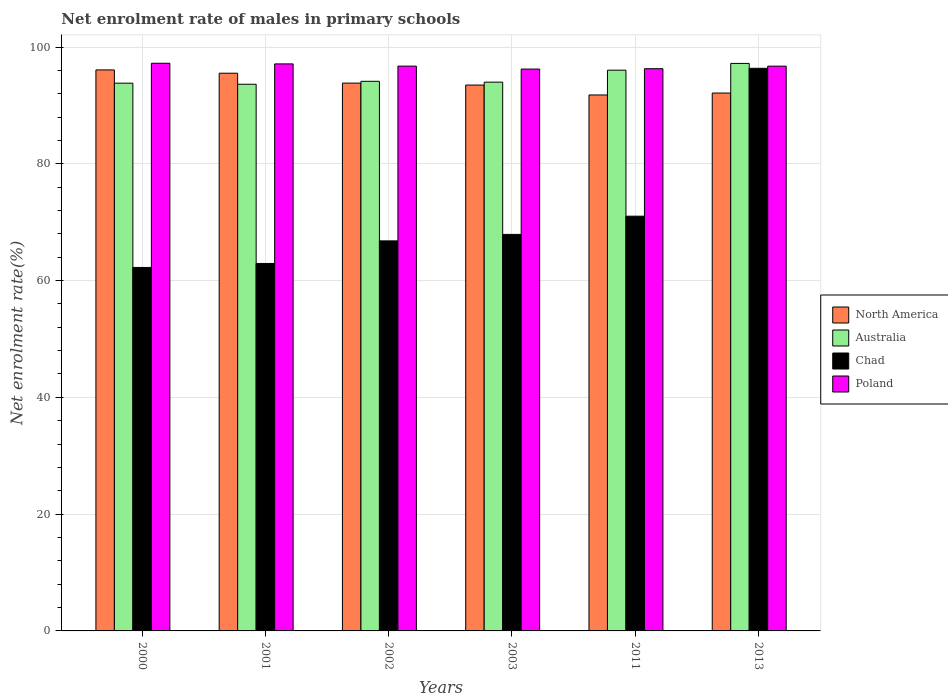How many groups of bars are there?
Offer a very short reply. 6. How many bars are there on the 6th tick from the right?
Ensure brevity in your answer.  4. In how many cases, is the number of bars for a given year not equal to the number of legend labels?
Your answer should be compact. 0. What is the net enrolment rate of males in primary schools in Australia in 2000?
Make the answer very short. 93.81. Across all years, what is the maximum net enrolment rate of males in primary schools in Poland?
Your answer should be very brief. 97.22. Across all years, what is the minimum net enrolment rate of males in primary schools in North America?
Offer a very short reply. 91.79. In which year was the net enrolment rate of males in primary schools in Chad minimum?
Provide a succinct answer. 2000. What is the total net enrolment rate of males in primary schools in North America in the graph?
Provide a short and direct response. 562.79. What is the difference between the net enrolment rate of males in primary schools in North America in 2003 and that in 2013?
Offer a terse response. 1.37. What is the difference between the net enrolment rate of males in primary schools in Poland in 2003 and the net enrolment rate of males in primary schools in North America in 2013?
Provide a succinct answer. 4.1. What is the average net enrolment rate of males in primary schools in Australia per year?
Offer a very short reply. 94.79. In the year 2013, what is the difference between the net enrolment rate of males in primary schools in North America and net enrolment rate of males in primary schools in Poland?
Your response must be concise. -4.61. In how many years, is the net enrolment rate of males in primary schools in Australia greater than 60 %?
Offer a very short reply. 6. What is the ratio of the net enrolment rate of males in primary schools in Australia in 2011 to that in 2013?
Your response must be concise. 0.99. What is the difference between the highest and the second highest net enrolment rate of males in primary schools in Chad?
Ensure brevity in your answer.  25.33. What is the difference between the highest and the lowest net enrolment rate of males in primary schools in Poland?
Your answer should be compact. 1. What does the 2nd bar from the right in 2013 represents?
Provide a succinct answer. Chad. Is it the case that in every year, the sum of the net enrolment rate of males in primary schools in Australia and net enrolment rate of males in primary schools in Chad is greater than the net enrolment rate of males in primary schools in Poland?
Give a very brief answer. Yes. How many bars are there?
Provide a succinct answer. 24. How many years are there in the graph?
Your response must be concise. 6. Are the values on the major ticks of Y-axis written in scientific E-notation?
Make the answer very short. No. Does the graph contain any zero values?
Offer a very short reply. No. Does the graph contain grids?
Provide a succinct answer. Yes. Where does the legend appear in the graph?
Offer a terse response. Center right. What is the title of the graph?
Give a very brief answer. Net enrolment rate of males in primary schools. Does "Lithuania" appear as one of the legend labels in the graph?
Provide a short and direct response. No. What is the label or title of the X-axis?
Your answer should be very brief. Years. What is the label or title of the Y-axis?
Make the answer very short. Net enrolment rate(%). What is the Net enrolment rate(%) of North America in 2000?
Ensure brevity in your answer.  96.08. What is the Net enrolment rate(%) in Australia in 2000?
Keep it short and to the point. 93.81. What is the Net enrolment rate(%) of Chad in 2000?
Keep it short and to the point. 62.25. What is the Net enrolment rate(%) in Poland in 2000?
Your answer should be very brief. 97.22. What is the Net enrolment rate(%) in North America in 2001?
Offer a terse response. 95.51. What is the Net enrolment rate(%) in Australia in 2001?
Give a very brief answer. 93.62. What is the Net enrolment rate(%) in Chad in 2001?
Provide a succinct answer. 62.93. What is the Net enrolment rate(%) in Poland in 2001?
Keep it short and to the point. 97.11. What is the Net enrolment rate(%) of North America in 2002?
Offer a very short reply. 93.82. What is the Net enrolment rate(%) in Australia in 2002?
Keep it short and to the point. 94.13. What is the Net enrolment rate(%) in Chad in 2002?
Give a very brief answer. 66.8. What is the Net enrolment rate(%) of Poland in 2002?
Keep it short and to the point. 96.73. What is the Net enrolment rate(%) in North America in 2003?
Give a very brief answer. 93.48. What is the Net enrolment rate(%) of Australia in 2003?
Ensure brevity in your answer.  93.98. What is the Net enrolment rate(%) in Chad in 2003?
Provide a short and direct response. 67.91. What is the Net enrolment rate(%) of Poland in 2003?
Your answer should be very brief. 96.22. What is the Net enrolment rate(%) of North America in 2011?
Your answer should be compact. 91.79. What is the Net enrolment rate(%) of Australia in 2011?
Offer a terse response. 96.03. What is the Net enrolment rate(%) in Chad in 2011?
Give a very brief answer. 71.03. What is the Net enrolment rate(%) of Poland in 2011?
Provide a short and direct response. 96.28. What is the Net enrolment rate(%) of North America in 2013?
Keep it short and to the point. 92.12. What is the Net enrolment rate(%) in Australia in 2013?
Offer a terse response. 97.19. What is the Net enrolment rate(%) in Chad in 2013?
Make the answer very short. 96.35. What is the Net enrolment rate(%) of Poland in 2013?
Offer a very short reply. 96.72. Across all years, what is the maximum Net enrolment rate(%) in North America?
Offer a terse response. 96.08. Across all years, what is the maximum Net enrolment rate(%) in Australia?
Offer a terse response. 97.19. Across all years, what is the maximum Net enrolment rate(%) of Chad?
Your answer should be very brief. 96.35. Across all years, what is the maximum Net enrolment rate(%) in Poland?
Provide a short and direct response. 97.22. Across all years, what is the minimum Net enrolment rate(%) in North America?
Offer a terse response. 91.79. Across all years, what is the minimum Net enrolment rate(%) of Australia?
Make the answer very short. 93.62. Across all years, what is the minimum Net enrolment rate(%) in Chad?
Your response must be concise. 62.25. Across all years, what is the minimum Net enrolment rate(%) of Poland?
Give a very brief answer. 96.22. What is the total Net enrolment rate(%) of North America in the graph?
Provide a short and direct response. 562.79. What is the total Net enrolment rate(%) of Australia in the graph?
Make the answer very short. 568.76. What is the total Net enrolment rate(%) in Chad in the graph?
Keep it short and to the point. 427.26. What is the total Net enrolment rate(%) of Poland in the graph?
Offer a terse response. 580.27. What is the difference between the Net enrolment rate(%) in North America in 2000 and that in 2001?
Your answer should be compact. 0.56. What is the difference between the Net enrolment rate(%) in Australia in 2000 and that in 2001?
Offer a very short reply. 0.18. What is the difference between the Net enrolment rate(%) in Chad in 2000 and that in 2001?
Make the answer very short. -0.68. What is the difference between the Net enrolment rate(%) of Poland in 2000 and that in 2001?
Provide a short and direct response. 0.11. What is the difference between the Net enrolment rate(%) of North America in 2000 and that in 2002?
Provide a short and direct response. 2.26. What is the difference between the Net enrolment rate(%) in Australia in 2000 and that in 2002?
Provide a short and direct response. -0.32. What is the difference between the Net enrolment rate(%) in Chad in 2000 and that in 2002?
Offer a terse response. -4.55. What is the difference between the Net enrolment rate(%) of Poland in 2000 and that in 2002?
Offer a very short reply. 0.49. What is the difference between the Net enrolment rate(%) in North America in 2000 and that in 2003?
Offer a terse response. 2.59. What is the difference between the Net enrolment rate(%) in Australia in 2000 and that in 2003?
Keep it short and to the point. -0.17. What is the difference between the Net enrolment rate(%) in Chad in 2000 and that in 2003?
Provide a succinct answer. -5.66. What is the difference between the Net enrolment rate(%) of North America in 2000 and that in 2011?
Keep it short and to the point. 4.29. What is the difference between the Net enrolment rate(%) of Australia in 2000 and that in 2011?
Provide a succinct answer. -2.23. What is the difference between the Net enrolment rate(%) in Chad in 2000 and that in 2011?
Your answer should be compact. -8.78. What is the difference between the Net enrolment rate(%) of Poland in 2000 and that in 2011?
Make the answer very short. 0.93. What is the difference between the Net enrolment rate(%) of North America in 2000 and that in 2013?
Your answer should be very brief. 3.96. What is the difference between the Net enrolment rate(%) in Australia in 2000 and that in 2013?
Provide a short and direct response. -3.38. What is the difference between the Net enrolment rate(%) in Chad in 2000 and that in 2013?
Offer a very short reply. -34.11. What is the difference between the Net enrolment rate(%) of Poland in 2000 and that in 2013?
Keep it short and to the point. 0.49. What is the difference between the Net enrolment rate(%) in North America in 2001 and that in 2002?
Your answer should be very brief. 1.69. What is the difference between the Net enrolment rate(%) in Australia in 2001 and that in 2002?
Your response must be concise. -0.5. What is the difference between the Net enrolment rate(%) of Chad in 2001 and that in 2002?
Make the answer very short. -3.87. What is the difference between the Net enrolment rate(%) of Poland in 2001 and that in 2002?
Provide a short and direct response. 0.38. What is the difference between the Net enrolment rate(%) in North America in 2001 and that in 2003?
Provide a short and direct response. 2.03. What is the difference between the Net enrolment rate(%) in Australia in 2001 and that in 2003?
Your answer should be compact. -0.36. What is the difference between the Net enrolment rate(%) of Chad in 2001 and that in 2003?
Provide a short and direct response. -4.98. What is the difference between the Net enrolment rate(%) of Poland in 2001 and that in 2003?
Give a very brief answer. 0.89. What is the difference between the Net enrolment rate(%) in North America in 2001 and that in 2011?
Offer a very short reply. 3.73. What is the difference between the Net enrolment rate(%) in Australia in 2001 and that in 2011?
Ensure brevity in your answer.  -2.41. What is the difference between the Net enrolment rate(%) in Chad in 2001 and that in 2011?
Provide a short and direct response. -8.1. What is the difference between the Net enrolment rate(%) in Poland in 2001 and that in 2011?
Give a very brief answer. 0.82. What is the difference between the Net enrolment rate(%) in North America in 2001 and that in 2013?
Offer a very short reply. 3.4. What is the difference between the Net enrolment rate(%) of Australia in 2001 and that in 2013?
Your response must be concise. -3.56. What is the difference between the Net enrolment rate(%) of Chad in 2001 and that in 2013?
Provide a succinct answer. -33.42. What is the difference between the Net enrolment rate(%) in Poland in 2001 and that in 2013?
Your answer should be compact. 0.38. What is the difference between the Net enrolment rate(%) in North America in 2002 and that in 2003?
Provide a succinct answer. 0.33. What is the difference between the Net enrolment rate(%) of Australia in 2002 and that in 2003?
Your answer should be compact. 0.15. What is the difference between the Net enrolment rate(%) of Chad in 2002 and that in 2003?
Offer a very short reply. -1.11. What is the difference between the Net enrolment rate(%) of Poland in 2002 and that in 2003?
Offer a terse response. 0.51. What is the difference between the Net enrolment rate(%) of North America in 2002 and that in 2011?
Give a very brief answer. 2.03. What is the difference between the Net enrolment rate(%) in Australia in 2002 and that in 2011?
Your answer should be very brief. -1.91. What is the difference between the Net enrolment rate(%) in Chad in 2002 and that in 2011?
Your answer should be compact. -4.23. What is the difference between the Net enrolment rate(%) of Poland in 2002 and that in 2011?
Keep it short and to the point. 0.44. What is the difference between the Net enrolment rate(%) of North America in 2002 and that in 2013?
Provide a short and direct response. 1.7. What is the difference between the Net enrolment rate(%) of Australia in 2002 and that in 2013?
Provide a succinct answer. -3.06. What is the difference between the Net enrolment rate(%) of Chad in 2002 and that in 2013?
Offer a terse response. -29.55. What is the difference between the Net enrolment rate(%) in Poland in 2002 and that in 2013?
Make the answer very short. 0. What is the difference between the Net enrolment rate(%) of North America in 2003 and that in 2011?
Provide a short and direct response. 1.7. What is the difference between the Net enrolment rate(%) in Australia in 2003 and that in 2011?
Provide a short and direct response. -2.05. What is the difference between the Net enrolment rate(%) in Chad in 2003 and that in 2011?
Provide a short and direct response. -3.12. What is the difference between the Net enrolment rate(%) in Poland in 2003 and that in 2011?
Your response must be concise. -0.06. What is the difference between the Net enrolment rate(%) in North America in 2003 and that in 2013?
Provide a short and direct response. 1.37. What is the difference between the Net enrolment rate(%) in Australia in 2003 and that in 2013?
Ensure brevity in your answer.  -3.21. What is the difference between the Net enrolment rate(%) of Chad in 2003 and that in 2013?
Your answer should be compact. -28.45. What is the difference between the Net enrolment rate(%) in Poland in 2003 and that in 2013?
Make the answer very short. -0.5. What is the difference between the Net enrolment rate(%) in North America in 2011 and that in 2013?
Give a very brief answer. -0.33. What is the difference between the Net enrolment rate(%) in Australia in 2011 and that in 2013?
Make the answer very short. -1.15. What is the difference between the Net enrolment rate(%) in Chad in 2011 and that in 2013?
Provide a short and direct response. -25.33. What is the difference between the Net enrolment rate(%) of Poland in 2011 and that in 2013?
Give a very brief answer. -0.44. What is the difference between the Net enrolment rate(%) of North America in 2000 and the Net enrolment rate(%) of Australia in 2001?
Provide a short and direct response. 2.45. What is the difference between the Net enrolment rate(%) in North America in 2000 and the Net enrolment rate(%) in Chad in 2001?
Offer a very short reply. 33.15. What is the difference between the Net enrolment rate(%) of North America in 2000 and the Net enrolment rate(%) of Poland in 2001?
Provide a succinct answer. -1.03. What is the difference between the Net enrolment rate(%) of Australia in 2000 and the Net enrolment rate(%) of Chad in 2001?
Your answer should be very brief. 30.88. What is the difference between the Net enrolment rate(%) in Australia in 2000 and the Net enrolment rate(%) in Poland in 2001?
Provide a succinct answer. -3.3. What is the difference between the Net enrolment rate(%) of Chad in 2000 and the Net enrolment rate(%) of Poland in 2001?
Offer a terse response. -34.86. What is the difference between the Net enrolment rate(%) of North America in 2000 and the Net enrolment rate(%) of Australia in 2002?
Keep it short and to the point. 1.95. What is the difference between the Net enrolment rate(%) of North America in 2000 and the Net enrolment rate(%) of Chad in 2002?
Offer a very short reply. 29.28. What is the difference between the Net enrolment rate(%) in North America in 2000 and the Net enrolment rate(%) in Poland in 2002?
Offer a very short reply. -0.65. What is the difference between the Net enrolment rate(%) in Australia in 2000 and the Net enrolment rate(%) in Chad in 2002?
Your response must be concise. 27.01. What is the difference between the Net enrolment rate(%) of Australia in 2000 and the Net enrolment rate(%) of Poland in 2002?
Your answer should be very brief. -2.92. What is the difference between the Net enrolment rate(%) in Chad in 2000 and the Net enrolment rate(%) in Poland in 2002?
Provide a succinct answer. -34.48. What is the difference between the Net enrolment rate(%) in North America in 2000 and the Net enrolment rate(%) in Australia in 2003?
Ensure brevity in your answer.  2.09. What is the difference between the Net enrolment rate(%) in North America in 2000 and the Net enrolment rate(%) in Chad in 2003?
Ensure brevity in your answer.  28.17. What is the difference between the Net enrolment rate(%) of North America in 2000 and the Net enrolment rate(%) of Poland in 2003?
Ensure brevity in your answer.  -0.15. What is the difference between the Net enrolment rate(%) in Australia in 2000 and the Net enrolment rate(%) in Chad in 2003?
Your response must be concise. 25.9. What is the difference between the Net enrolment rate(%) of Australia in 2000 and the Net enrolment rate(%) of Poland in 2003?
Provide a short and direct response. -2.41. What is the difference between the Net enrolment rate(%) in Chad in 2000 and the Net enrolment rate(%) in Poland in 2003?
Provide a short and direct response. -33.97. What is the difference between the Net enrolment rate(%) of North America in 2000 and the Net enrolment rate(%) of Australia in 2011?
Ensure brevity in your answer.  0.04. What is the difference between the Net enrolment rate(%) of North America in 2000 and the Net enrolment rate(%) of Chad in 2011?
Keep it short and to the point. 25.05. What is the difference between the Net enrolment rate(%) in North America in 2000 and the Net enrolment rate(%) in Poland in 2011?
Keep it short and to the point. -0.21. What is the difference between the Net enrolment rate(%) of Australia in 2000 and the Net enrolment rate(%) of Chad in 2011?
Provide a short and direct response. 22.78. What is the difference between the Net enrolment rate(%) of Australia in 2000 and the Net enrolment rate(%) of Poland in 2011?
Offer a terse response. -2.47. What is the difference between the Net enrolment rate(%) of Chad in 2000 and the Net enrolment rate(%) of Poland in 2011?
Keep it short and to the point. -34.03. What is the difference between the Net enrolment rate(%) of North America in 2000 and the Net enrolment rate(%) of Australia in 2013?
Your answer should be compact. -1.11. What is the difference between the Net enrolment rate(%) in North America in 2000 and the Net enrolment rate(%) in Chad in 2013?
Ensure brevity in your answer.  -0.28. What is the difference between the Net enrolment rate(%) in North America in 2000 and the Net enrolment rate(%) in Poland in 2013?
Provide a succinct answer. -0.65. What is the difference between the Net enrolment rate(%) of Australia in 2000 and the Net enrolment rate(%) of Chad in 2013?
Make the answer very short. -2.55. What is the difference between the Net enrolment rate(%) in Australia in 2000 and the Net enrolment rate(%) in Poland in 2013?
Make the answer very short. -2.92. What is the difference between the Net enrolment rate(%) of Chad in 2000 and the Net enrolment rate(%) of Poland in 2013?
Keep it short and to the point. -34.48. What is the difference between the Net enrolment rate(%) in North America in 2001 and the Net enrolment rate(%) in Australia in 2002?
Your answer should be very brief. 1.39. What is the difference between the Net enrolment rate(%) in North America in 2001 and the Net enrolment rate(%) in Chad in 2002?
Your answer should be very brief. 28.71. What is the difference between the Net enrolment rate(%) of North America in 2001 and the Net enrolment rate(%) of Poland in 2002?
Provide a short and direct response. -1.21. What is the difference between the Net enrolment rate(%) of Australia in 2001 and the Net enrolment rate(%) of Chad in 2002?
Your answer should be very brief. 26.83. What is the difference between the Net enrolment rate(%) in Australia in 2001 and the Net enrolment rate(%) in Poland in 2002?
Your answer should be very brief. -3.1. What is the difference between the Net enrolment rate(%) in Chad in 2001 and the Net enrolment rate(%) in Poland in 2002?
Your answer should be compact. -33.8. What is the difference between the Net enrolment rate(%) in North America in 2001 and the Net enrolment rate(%) in Australia in 2003?
Provide a succinct answer. 1.53. What is the difference between the Net enrolment rate(%) in North America in 2001 and the Net enrolment rate(%) in Chad in 2003?
Offer a terse response. 27.61. What is the difference between the Net enrolment rate(%) in North America in 2001 and the Net enrolment rate(%) in Poland in 2003?
Keep it short and to the point. -0.71. What is the difference between the Net enrolment rate(%) of Australia in 2001 and the Net enrolment rate(%) of Chad in 2003?
Offer a terse response. 25.72. What is the difference between the Net enrolment rate(%) of Australia in 2001 and the Net enrolment rate(%) of Poland in 2003?
Your answer should be very brief. -2.6. What is the difference between the Net enrolment rate(%) in Chad in 2001 and the Net enrolment rate(%) in Poland in 2003?
Provide a succinct answer. -33.29. What is the difference between the Net enrolment rate(%) of North America in 2001 and the Net enrolment rate(%) of Australia in 2011?
Give a very brief answer. -0.52. What is the difference between the Net enrolment rate(%) in North America in 2001 and the Net enrolment rate(%) in Chad in 2011?
Your answer should be very brief. 24.49. What is the difference between the Net enrolment rate(%) of North America in 2001 and the Net enrolment rate(%) of Poland in 2011?
Keep it short and to the point. -0.77. What is the difference between the Net enrolment rate(%) in Australia in 2001 and the Net enrolment rate(%) in Chad in 2011?
Your answer should be very brief. 22.6. What is the difference between the Net enrolment rate(%) in Australia in 2001 and the Net enrolment rate(%) in Poland in 2011?
Offer a very short reply. -2.66. What is the difference between the Net enrolment rate(%) in Chad in 2001 and the Net enrolment rate(%) in Poland in 2011?
Make the answer very short. -33.35. What is the difference between the Net enrolment rate(%) in North America in 2001 and the Net enrolment rate(%) in Australia in 2013?
Ensure brevity in your answer.  -1.68. What is the difference between the Net enrolment rate(%) in North America in 2001 and the Net enrolment rate(%) in Chad in 2013?
Your response must be concise. -0.84. What is the difference between the Net enrolment rate(%) in North America in 2001 and the Net enrolment rate(%) in Poland in 2013?
Make the answer very short. -1.21. What is the difference between the Net enrolment rate(%) of Australia in 2001 and the Net enrolment rate(%) of Chad in 2013?
Your answer should be very brief. -2.73. What is the difference between the Net enrolment rate(%) of Australia in 2001 and the Net enrolment rate(%) of Poland in 2013?
Make the answer very short. -3.1. What is the difference between the Net enrolment rate(%) of Chad in 2001 and the Net enrolment rate(%) of Poland in 2013?
Keep it short and to the point. -33.79. What is the difference between the Net enrolment rate(%) of North America in 2002 and the Net enrolment rate(%) of Australia in 2003?
Give a very brief answer. -0.16. What is the difference between the Net enrolment rate(%) of North America in 2002 and the Net enrolment rate(%) of Chad in 2003?
Your response must be concise. 25.91. What is the difference between the Net enrolment rate(%) in North America in 2002 and the Net enrolment rate(%) in Poland in 2003?
Give a very brief answer. -2.4. What is the difference between the Net enrolment rate(%) in Australia in 2002 and the Net enrolment rate(%) in Chad in 2003?
Your response must be concise. 26.22. What is the difference between the Net enrolment rate(%) of Australia in 2002 and the Net enrolment rate(%) of Poland in 2003?
Give a very brief answer. -2.09. What is the difference between the Net enrolment rate(%) in Chad in 2002 and the Net enrolment rate(%) in Poland in 2003?
Your answer should be very brief. -29.42. What is the difference between the Net enrolment rate(%) of North America in 2002 and the Net enrolment rate(%) of Australia in 2011?
Provide a short and direct response. -2.22. What is the difference between the Net enrolment rate(%) in North America in 2002 and the Net enrolment rate(%) in Chad in 2011?
Keep it short and to the point. 22.79. What is the difference between the Net enrolment rate(%) in North America in 2002 and the Net enrolment rate(%) in Poland in 2011?
Provide a short and direct response. -2.46. What is the difference between the Net enrolment rate(%) of Australia in 2002 and the Net enrolment rate(%) of Chad in 2011?
Your answer should be very brief. 23.1. What is the difference between the Net enrolment rate(%) of Australia in 2002 and the Net enrolment rate(%) of Poland in 2011?
Your answer should be very brief. -2.15. What is the difference between the Net enrolment rate(%) in Chad in 2002 and the Net enrolment rate(%) in Poland in 2011?
Provide a succinct answer. -29.48. What is the difference between the Net enrolment rate(%) of North America in 2002 and the Net enrolment rate(%) of Australia in 2013?
Your answer should be compact. -3.37. What is the difference between the Net enrolment rate(%) in North America in 2002 and the Net enrolment rate(%) in Chad in 2013?
Your answer should be very brief. -2.53. What is the difference between the Net enrolment rate(%) in North America in 2002 and the Net enrolment rate(%) in Poland in 2013?
Your response must be concise. -2.9. What is the difference between the Net enrolment rate(%) in Australia in 2002 and the Net enrolment rate(%) in Chad in 2013?
Offer a very short reply. -2.23. What is the difference between the Net enrolment rate(%) of Australia in 2002 and the Net enrolment rate(%) of Poland in 2013?
Provide a short and direct response. -2.6. What is the difference between the Net enrolment rate(%) of Chad in 2002 and the Net enrolment rate(%) of Poland in 2013?
Provide a succinct answer. -29.92. What is the difference between the Net enrolment rate(%) in North America in 2003 and the Net enrolment rate(%) in Australia in 2011?
Your answer should be compact. -2.55. What is the difference between the Net enrolment rate(%) of North America in 2003 and the Net enrolment rate(%) of Chad in 2011?
Offer a terse response. 22.46. What is the difference between the Net enrolment rate(%) of North America in 2003 and the Net enrolment rate(%) of Poland in 2011?
Keep it short and to the point. -2.8. What is the difference between the Net enrolment rate(%) in Australia in 2003 and the Net enrolment rate(%) in Chad in 2011?
Give a very brief answer. 22.95. What is the difference between the Net enrolment rate(%) in Australia in 2003 and the Net enrolment rate(%) in Poland in 2011?
Give a very brief answer. -2.3. What is the difference between the Net enrolment rate(%) in Chad in 2003 and the Net enrolment rate(%) in Poland in 2011?
Your answer should be very brief. -28.37. What is the difference between the Net enrolment rate(%) of North America in 2003 and the Net enrolment rate(%) of Australia in 2013?
Your response must be concise. -3.7. What is the difference between the Net enrolment rate(%) of North America in 2003 and the Net enrolment rate(%) of Chad in 2013?
Your answer should be compact. -2.87. What is the difference between the Net enrolment rate(%) in North America in 2003 and the Net enrolment rate(%) in Poland in 2013?
Give a very brief answer. -3.24. What is the difference between the Net enrolment rate(%) of Australia in 2003 and the Net enrolment rate(%) of Chad in 2013?
Your answer should be compact. -2.37. What is the difference between the Net enrolment rate(%) of Australia in 2003 and the Net enrolment rate(%) of Poland in 2013?
Offer a very short reply. -2.74. What is the difference between the Net enrolment rate(%) in Chad in 2003 and the Net enrolment rate(%) in Poland in 2013?
Provide a succinct answer. -28.82. What is the difference between the Net enrolment rate(%) in North America in 2011 and the Net enrolment rate(%) in Australia in 2013?
Keep it short and to the point. -5.4. What is the difference between the Net enrolment rate(%) of North America in 2011 and the Net enrolment rate(%) of Chad in 2013?
Keep it short and to the point. -4.57. What is the difference between the Net enrolment rate(%) of North America in 2011 and the Net enrolment rate(%) of Poland in 2013?
Offer a very short reply. -4.94. What is the difference between the Net enrolment rate(%) in Australia in 2011 and the Net enrolment rate(%) in Chad in 2013?
Offer a terse response. -0.32. What is the difference between the Net enrolment rate(%) of Australia in 2011 and the Net enrolment rate(%) of Poland in 2013?
Provide a short and direct response. -0.69. What is the difference between the Net enrolment rate(%) of Chad in 2011 and the Net enrolment rate(%) of Poland in 2013?
Your answer should be compact. -25.7. What is the average Net enrolment rate(%) of North America per year?
Ensure brevity in your answer.  93.8. What is the average Net enrolment rate(%) in Australia per year?
Your answer should be very brief. 94.79. What is the average Net enrolment rate(%) in Chad per year?
Provide a short and direct response. 71.21. What is the average Net enrolment rate(%) of Poland per year?
Give a very brief answer. 96.71. In the year 2000, what is the difference between the Net enrolment rate(%) of North America and Net enrolment rate(%) of Australia?
Your response must be concise. 2.27. In the year 2000, what is the difference between the Net enrolment rate(%) in North America and Net enrolment rate(%) in Chad?
Offer a very short reply. 33.83. In the year 2000, what is the difference between the Net enrolment rate(%) of North America and Net enrolment rate(%) of Poland?
Keep it short and to the point. -1.14. In the year 2000, what is the difference between the Net enrolment rate(%) in Australia and Net enrolment rate(%) in Chad?
Offer a terse response. 31.56. In the year 2000, what is the difference between the Net enrolment rate(%) in Australia and Net enrolment rate(%) in Poland?
Offer a very short reply. -3.41. In the year 2000, what is the difference between the Net enrolment rate(%) in Chad and Net enrolment rate(%) in Poland?
Offer a terse response. -34.97. In the year 2001, what is the difference between the Net enrolment rate(%) of North America and Net enrolment rate(%) of Australia?
Provide a short and direct response. 1.89. In the year 2001, what is the difference between the Net enrolment rate(%) of North America and Net enrolment rate(%) of Chad?
Offer a very short reply. 32.58. In the year 2001, what is the difference between the Net enrolment rate(%) of North America and Net enrolment rate(%) of Poland?
Your answer should be compact. -1.59. In the year 2001, what is the difference between the Net enrolment rate(%) of Australia and Net enrolment rate(%) of Chad?
Your answer should be very brief. 30.7. In the year 2001, what is the difference between the Net enrolment rate(%) in Australia and Net enrolment rate(%) in Poland?
Offer a very short reply. -3.48. In the year 2001, what is the difference between the Net enrolment rate(%) in Chad and Net enrolment rate(%) in Poland?
Your answer should be very brief. -34.18. In the year 2002, what is the difference between the Net enrolment rate(%) of North America and Net enrolment rate(%) of Australia?
Keep it short and to the point. -0.31. In the year 2002, what is the difference between the Net enrolment rate(%) of North America and Net enrolment rate(%) of Chad?
Make the answer very short. 27.02. In the year 2002, what is the difference between the Net enrolment rate(%) in North America and Net enrolment rate(%) in Poland?
Provide a short and direct response. -2.91. In the year 2002, what is the difference between the Net enrolment rate(%) of Australia and Net enrolment rate(%) of Chad?
Provide a succinct answer. 27.33. In the year 2002, what is the difference between the Net enrolment rate(%) in Australia and Net enrolment rate(%) in Poland?
Your answer should be compact. -2.6. In the year 2002, what is the difference between the Net enrolment rate(%) of Chad and Net enrolment rate(%) of Poland?
Make the answer very short. -29.93. In the year 2003, what is the difference between the Net enrolment rate(%) in North America and Net enrolment rate(%) in Australia?
Give a very brief answer. -0.5. In the year 2003, what is the difference between the Net enrolment rate(%) in North America and Net enrolment rate(%) in Chad?
Your answer should be compact. 25.58. In the year 2003, what is the difference between the Net enrolment rate(%) of North America and Net enrolment rate(%) of Poland?
Your response must be concise. -2.74. In the year 2003, what is the difference between the Net enrolment rate(%) of Australia and Net enrolment rate(%) of Chad?
Offer a terse response. 26.07. In the year 2003, what is the difference between the Net enrolment rate(%) in Australia and Net enrolment rate(%) in Poland?
Your answer should be very brief. -2.24. In the year 2003, what is the difference between the Net enrolment rate(%) of Chad and Net enrolment rate(%) of Poland?
Make the answer very short. -28.31. In the year 2011, what is the difference between the Net enrolment rate(%) of North America and Net enrolment rate(%) of Australia?
Provide a short and direct response. -4.25. In the year 2011, what is the difference between the Net enrolment rate(%) of North America and Net enrolment rate(%) of Chad?
Provide a succinct answer. 20.76. In the year 2011, what is the difference between the Net enrolment rate(%) of North America and Net enrolment rate(%) of Poland?
Make the answer very short. -4.5. In the year 2011, what is the difference between the Net enrolment rate(%) in Australia and Net enrolment rate(%) in Chad?
Give a very brief answer. 25.01. In the year 2011, what is the difference between the Net enrolment rate(%) in Australia and Net enrolment rate(%) in Poland?
Keep it short and to the point. -0.25. In the year 2011, what is the difference between the Net enrolment rate(%) of Chad and Net enrolment rate(%) of Poland?
Keep it short and to the point. -25.25. In the year 2013, what is the difference between the Net enrolment rate(%) in North America and Net enrolment rate(%) in Australia?
Offer a very short reply. -5.07. In the year 2013, what is the difference between the Net enrolment rate(%) of North America and Net enrolment rate(%) of Chad?
Make the answer very short. -4.24. In the year 2013, what is the difference between the Net enrolment rate(%) in North America and Net enrolment rate(%) in Poland?
Your answer should be very brief. -4.61. In the year 2013, what is the difference between the Net enrolment rate(%) in Australia and Net enrolment rate(%) in Chad?
Offer a very short reply. 0.84. In the year 2013, what is the difference between the Net enrolment rate(%) in Australia and Net enrolment rate(%) in Poland?
Your answer should be very brief. 0.47. In the year 2013, what is the difference between the Net enrolment rate(%) in Chad and Net enrolment rate(%) in Poland?
Provide a succinct answer. -0.37. What is the ratio of the Net enrolment rate(%) in North America in 2000 to that in 2001?
Offer a very short reply. 1.01. What is the ratio of the Net enrolment rate(%) of Chad in 2000 to that in 2001?
Offer a very short reply. 0.99. What is the ratio of the Net enrolment rate(%) of Poland in 2000 to that in 2001?
Give a very brief answer. 1. What is the ratio of the Net enrolment rate(%) in North America in 2000 to that in 2002?
Make the answer very short. 1.02. What is the ratio of the Net enrolment rate(%) of Australia in 2000 to that in 2002?
Provide a short and direct response. 1. What is the ratio of the Net enrolment rate(%) in Chad in 2000 to that in 2002?
Offer a terse response. 0.93. What is the ratio of the Net enrolment rate(%) in Poland in 2000 to that in 2002?
Ensure brevity in your answer.  1.01. What is the ratio of the Net enrolment rate(%) of North America in 2000 to that in 2003?
Provide a succinct answer. 1.03. What is the ratio of the Net enrolment rate(%) of Australia in 2000 to that in 2003?
Your answer should be compact. 1. What is the ratio of the Net enrolment rate(%) of Chad in 2000 to that in 2003?
Give a very brief answer. 0.92. What is the ratio of the Net enrolment rate(%) in Poland in 2000 to that in 2003?
Make the answer very short. 1.01. What is the ratio of the Net enrolment rate(%) in North America in 2000 to that in 2011?
Give a very brief answer. 1.05. What is the ratio of the Net enrolment rate(%) of Australia in 2000 to that in 2011?
Ensure brevity in your answer.  0.98. What is the ratio of the Net enrolment rate(%) of Chad in 2000 to that in 2011?
Your answer should be very brief. 0.88. What is the ratio of the Net enrolment rate(%) in Poland in 2000 to that in 2011?
Your answer should be very brief. 1.01. What is the ratio of the Net enrolment rate(%) of North America in 2000 to that in 2013?
Provide a succinct answer. 1.04. What is the ratio of the Net enrolment rate(%) of Australia in 2000 to that in 2013?
Offer a very short reply. 0.97. What is the ratio of the Net enrolment rate(%) in Chad in 2000 to that in 2013?
Keep it short and to the point. 0.65. What is the ratio of the Net enrolment rate(%) of North America in 2001 to that in 2002?
Offer a very short reply. 1.02. What is the ratio of the Net enrolment rate(%) in Australia in 2001 to that in 2002?
Ensure brevity in your answer.  0.99. What is the ratio of the Net enrolment rate(%) in Chad in 2001 to that in 2002?
Provide a short and direct response. 0.94. What is the ratio of the Net enrolment rate(%) of Poland in 2001 to that in 2002?
Your response must be concise. 1. What is the ratio of the Net enrolment rate(%) of North America in 2001 to that in 2003?
Offer a terse response. 1.02. What is the ratio of the Net enrolment rate(%) in Chad in 2001 to that in 2003?
Ensure brevity in your answer.  0.93. What is the ratio of the Net enrolment rate(%) in Poland in 2001 to that in 2003?
Provide a short and direct response. 1.01. What is the ratio of the Net enrolment rate(%) in North America in 2001 to that in 2011?
Give a very brief answer. 1.04. What is the ratio of the Net enrolment rate(%) of Australia in 2001 to that in 2011?
Keep it short and to the point. 0.97. What is the ratio of the Net enrolment rate(%) of Chad in 2001 to that in 2011?
Offer a very short reply. 0.89. What is the ratio of the Net enrolment rate(%) of Poland in 2001 to that in 2011?
Offer a terse response. 1.01. What is the ratio of the Net enrolment rate(%) of North America in 2001 to that in 2013?
Provide a short and direct response. 1.04. What is the ratio of the Net enrolment rate(%) in Australia in 2001 to that in 2013?
Provide a short and direct response. 0.96. What is the ratio of the Net enrolment rate(%) in Chad in 2001 to that in 2013?
Make the answer very short. 0.65. What is the ratio of the Net enrolment rate(%) in Poland in 2001 to that in 2013?
Provide a short and direct response. 1. What is the ratio of the Net enrolment rate(%) of North America in 2002 to that in 2003?
Offer a very short reply. 1. What is the ratio of the Net enrolment rate(%) in Australia in 2002 to that in 2003?
Give a very brief answer. 1. What is the ratio of the Net enrolment rate(%) in Chad in 2002 to that in 2003?
Make the answer very short. 0.98. What is the ratio of the Net enrolment rate(%) in Poland in 2002 to that in 2003?
Offer a terse response. 1.01. What is the ratio of the Net enrolment rate(%) of North America in 2002 to that in 2011?
Offer a terse response. 1.02. What is the ratio of the Net enrolment rate(%) of Australia in 2002 to that in 2011?
Keep it short and to the point. 0.98. What is the ratio of the Net enrolment rate(%) of Chad in 2002 to that in 2011?
Offer a terse response. 0.94. What is the ratio of the Net enrolment rate(%) in North America in 2002 to that in 2013?
Offer a terse response. 1.02. What is the ratio of the Net enrolment rate(%) of Australia in 2002 to that in 2013?
Provide a succinct answer. 0.97. What is the ratio of the Net enrolment rate(%) of Chad in 2002 to that in 2013?
Provide a succinct answer. 0.69. What is the ratio of the Net enrolment rate(%) in North America in 2003 to that in 2011?
Give a very brief answer. 1.02. What is the ratio of the Net enrolment rate(%) of Australia in 2003 to that in 2011?
Your response must be concise. 0.98. What is the ratio of the Net enrolment rate(%) in Chad in 2003 to that in 2011?
Offer a very short reply. 0.96. What is the ratio of the Net enrolment rate(%) in Poland in 2003 to that in 2011?
Keep it short and to the point. 1. What is the ratio of the Net enrolment rate(%) of North America in 2003 to that in 2013?
Offer a terse response. 1.01. What is the ratio of the Net enrolment rate(%) in Chad in 2003 to that in 2013?
Offer a terse response. 0.7. What is the ratio of the Net enrolment rate(%) of Chad in 2011 to that in 2013?
Keep it short and to the point. 0.74. What is the difference between the highest and the second highest Net enrolment rate(%) of North America?
Make the answer very short. 0.56. What is the difference between the highest and the second highest Net enrolment rate(%) of Australia?
Your response must be concise. 1.15. What is the difference between the highest and the second highest Net enrolment rate(%) in Chad?
Your response must be concise. 25.33. What is the difference between the highest and the second highest Net enrolment rate(%) in Poland?
Ensure brevity in your answer.  0.11. What is the difference between the highest and the lowest Net enrolment rate(%) in North America?
Provide a short and direct response. 4.29. What is the difference between the highest and the lowest Net enrolment rate(%) in Australia?
Your response must be concise. 3.56. What is the difference between the highest and the lowest Net enrolment rate(%) of Chad?
Give a very brief answer. 34.11. 